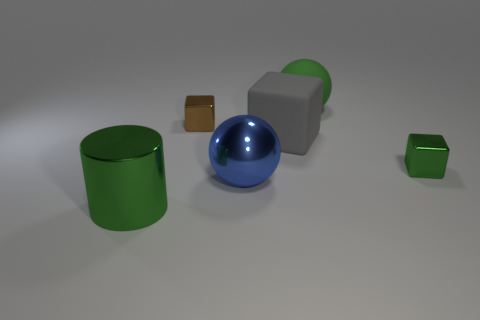Is the metallic ball the same color as the large cube? No, the metallic ball is not the same color as the large cube. The ball has a reflective blue surface, while the large cube appears to be more of a matte gray color. 